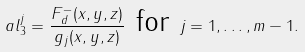<formula> <loc_0><loc_0><loc_500><loc_500>\ a l _ { 3 } ^ { j } = \frac { F _ { d } ^ { - } ( x , y , z ) } { g _ { j } ( x , y , z ) } \text { for } j = 1 , \dots , m - 1 .</formula> 